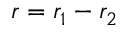Convert formula to latex. <formula><loc_0><loc_0><loc_500><loc_500>r = r _ { 1 } - r _ { 2 }</formula> 